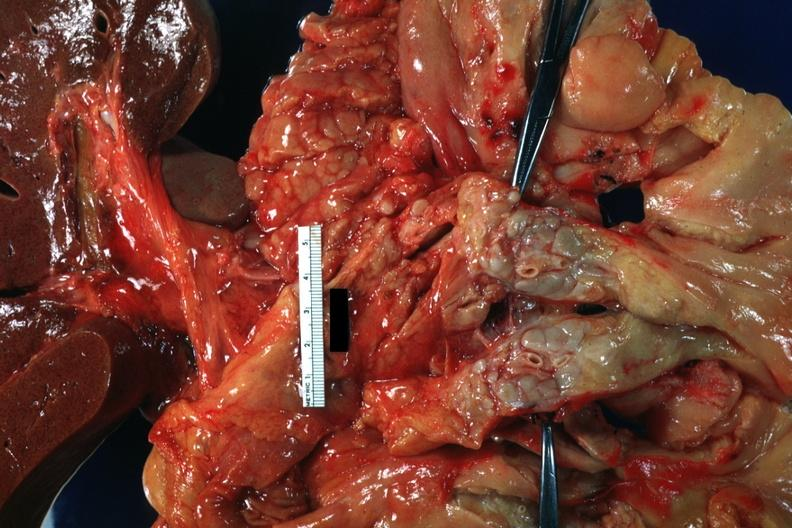what is present?
Answer the question using a single word or phrase. Metastatic carcinoid 